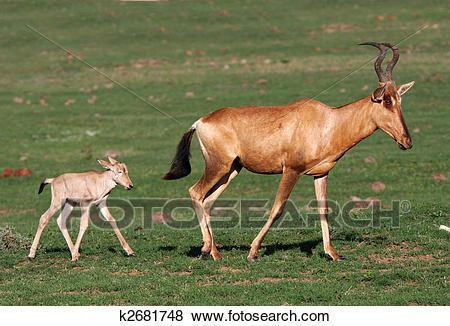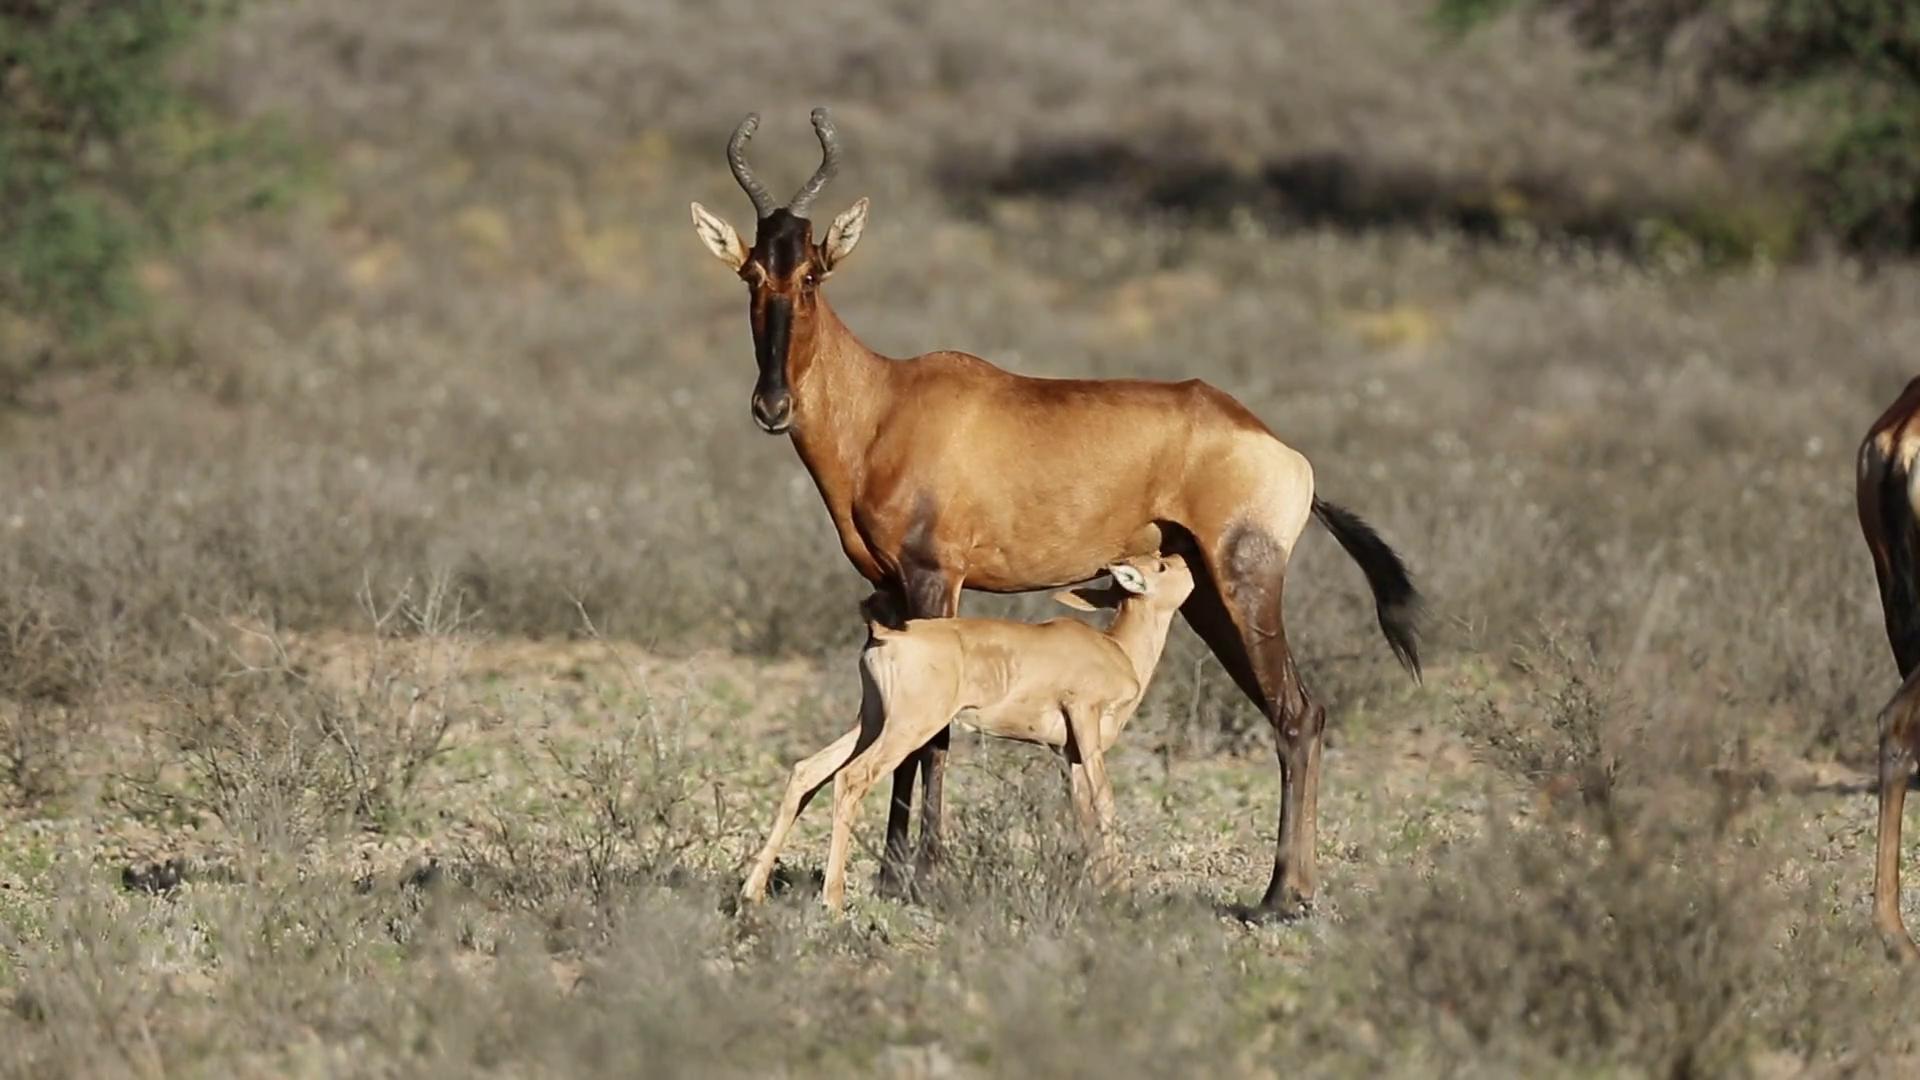The first image is the image on the left, the second image is the image on the right. Considering the images on both sides, is "An image shows a rightward-facing adult horned animal and young hornless animal, one ahead of the other but not overlapping." valid? Answer yes or no. Yes. 